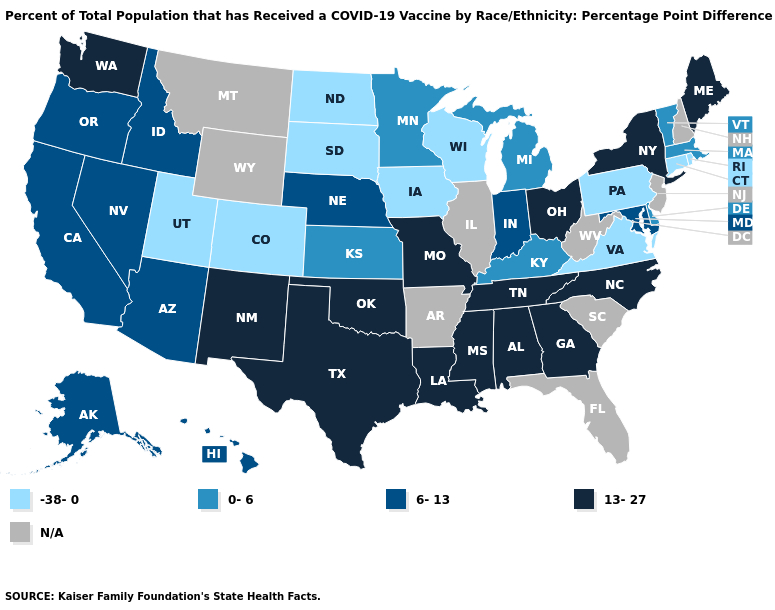Which states have the highest value in the USA?
Be succinct. Alabama, Georgia, Louisiana, Maine, Mississippi, Missouri, New Mexico, New York, North Carolina, Ohio, Oklahoma, Tennessee, Texas, Washington. What is the value of Pennsylvania?
Short answer required. -38-0. What is the value of Hawaii?
Concise answer only. 6-13. What is the value of Kentucky?
Keep it brief. 0-6. Name the states that have a value in the range 0-6?
Short answer required. Delaware, Kansas, Kentucky, Massachusetts, Michigan, Minnesota, Vermont. What is the value of Idaho?
Keep it brief. 6-13. Name the states that have a value in the range N/A?
Short answer required. Arkansas, Florida, Illinois, Montana, New Hampshire, New Jersey, South Carolina, West Virginia, Wyoming. Among the states that border Massachusetts , does Connecticut have the lowest value?
Keep it brief. Yes. What is the value of Arkansas?
Answer briefly. N/A. Does Pennsylvania have the lowest value in the Northeast?
Give a very brief answer. Yes. Does the first symbol in the legend represent the smallest category?
Be succinct. Yes. Name the states that have a value in the range 13-27?
Keep it brief. Alabama, Georgia, Louisiana, Maine, Mississippi, Missouri, New Mexico, New York, North Carolina, Ohio, Oklahoma, Tennessee, Texas, Washington. Name the states that have a value in the range 13-27?
Keep it brief. Alabama, Georgia, Louisiana, Maine, Mississippi, Missouri, New Mexico, New York, North Carolina, Ohio, Oklahoma, Tennessee, Texas, Washington. 